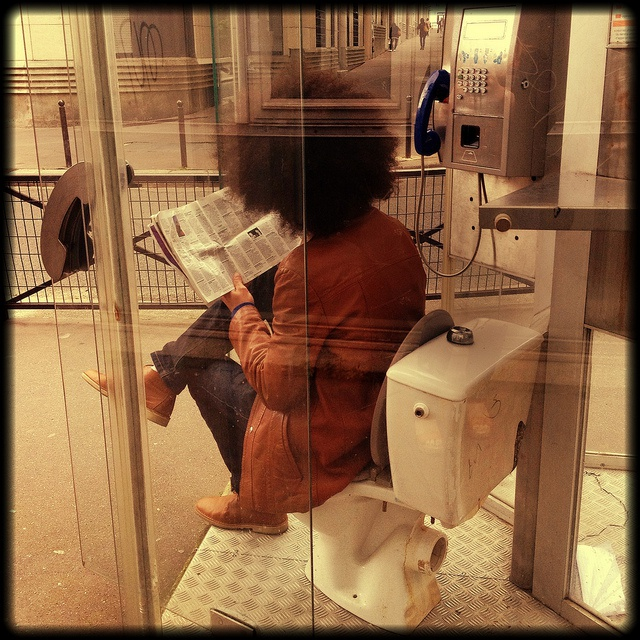Describe the objects in this image and their specific colors. I can see people in black, maroon, and brown tones, toilet in black, tan, and brown tones, and people in black, brown, tan, and maroon tones in this image. 